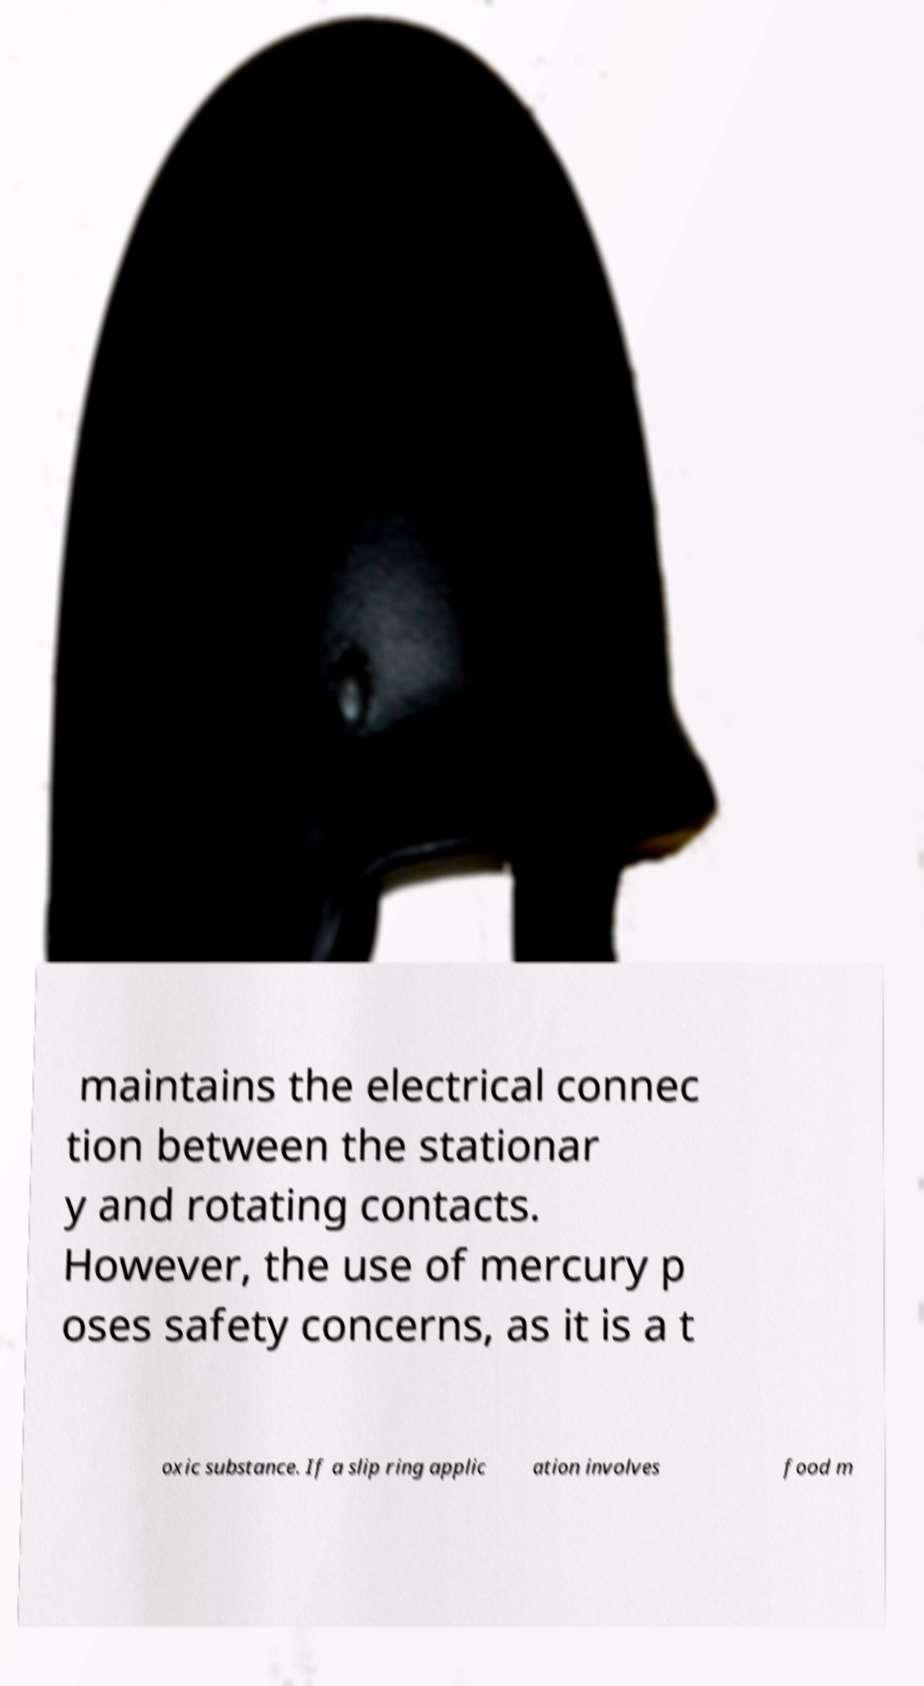What messages or text are displayed in this image? I need them in a readable, typed format. maintains the electrical connec tion between the stationar y and rotating contacts. However, the use of mercury p oses safety concerns, as it is a t oxic substance. If a slip ring applic ation involves food m 